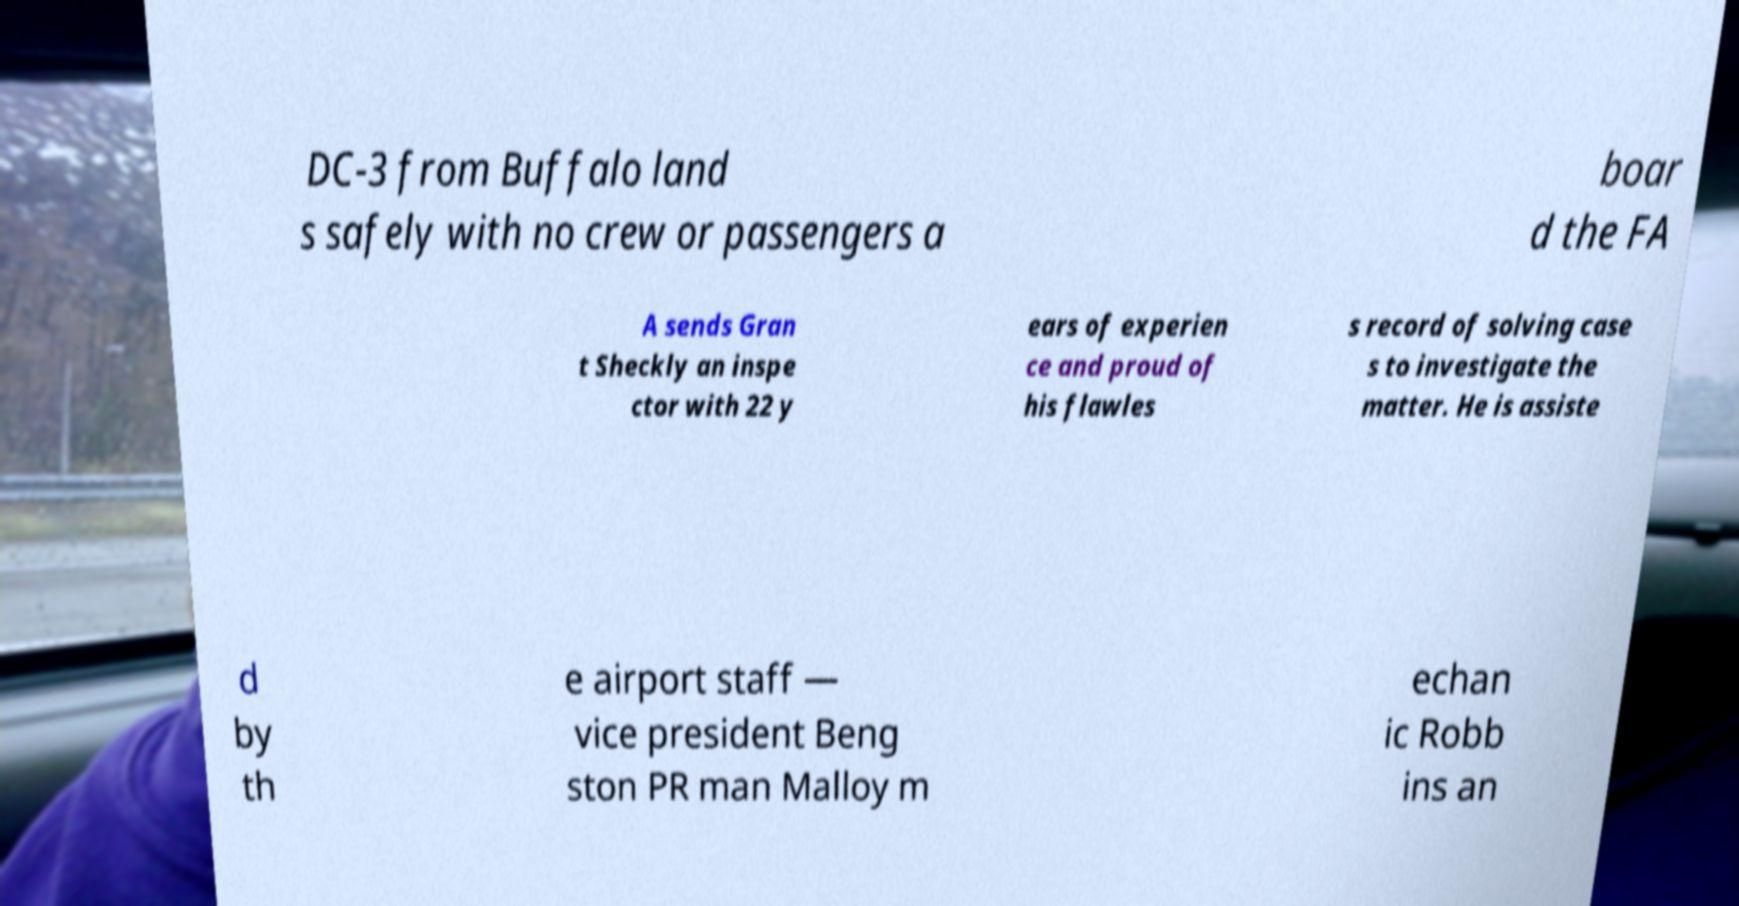There's text embedded in this image that I need extracted. Can you transcribe it verbatim? DC-3 from Buffalo land s safely with no crew or passengers a boar d the FA A sends Gran t Sheckly an inspe ctor with 22 y ears of experien ce and proud of his flawles s record of solving case s to investigate the matter. He is assiste d by th e airport staff — vice president Beng ston PR man Malloy m echan ic Robb ins an 